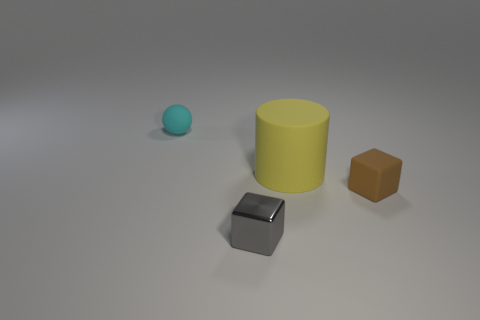Add 1 big blue metal blocks. How many objects exist? 5 Subtract all brown cubes. How many cubes are left? 1 Subtract all balls. How many objects are left? 3 Subtract 1 cylinders. How many cylinders are left? 0 Subtract all large cyan shiny cubes. Subtract all large yellow objects. How many objects are left? 3 Add 3 big cylinders. How many big cylinders are left? 4 Add 3 green metallic cubes. How many green metallic cubes exist? 3 Subtract 1 yellow cylinders. How many objects are left? 3 Subtract all green cubes. Subtract all brown balls. How many cubes are left? 2 Subtract all cyan balls. How many cyan cylinders are left? 0 